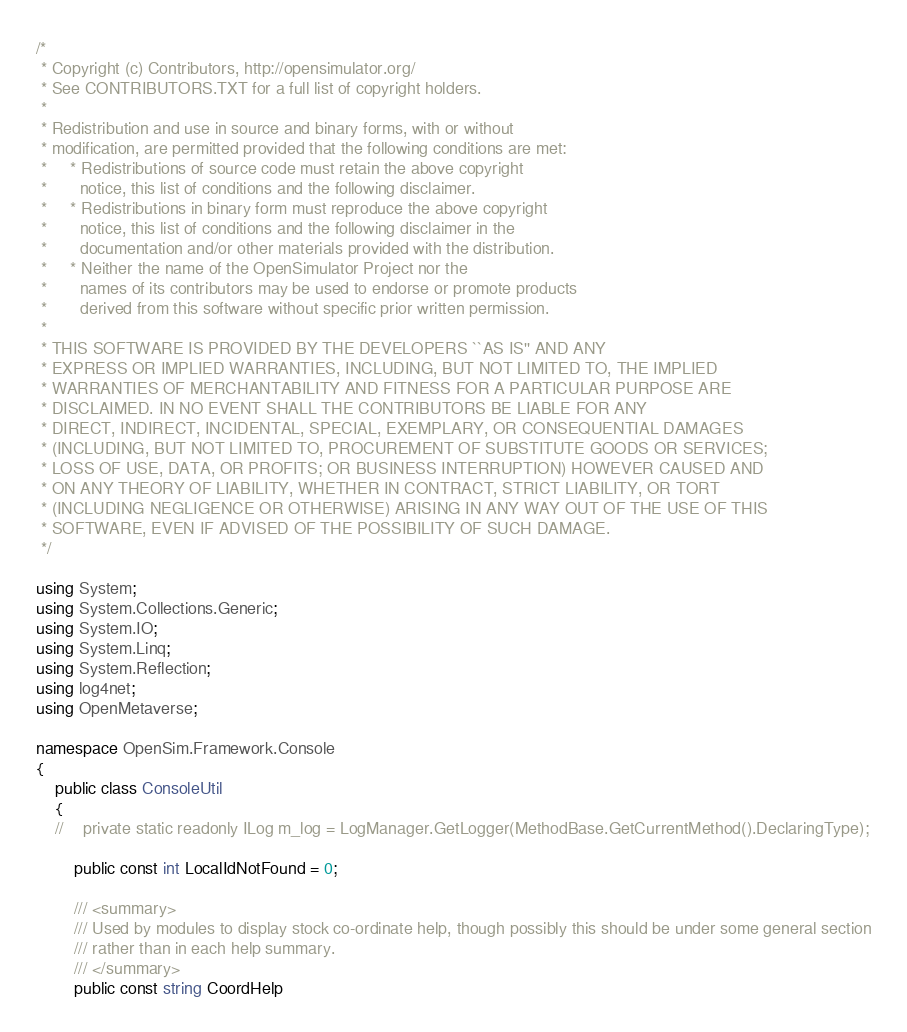<code> <loc_0><loc_0><loc_500><loc_500><_C#_>/*
 * Copyright (c) Contributors, http://opensimulator.org/
 * See CONTRIBUTORS.TXT for a full list of copyright holders.
 *
 * Redistribution and use in source and binary forms, with or without
 * modification, are permitted provided that the following conditions are met:
 *     * Redistributions of source code must retain the above copyright
 *       notice, this list of conditions and the following disclaimer.
 *     * Redistributions in binary form must reproduce the above copyright
 *       notice, this list of conditions and the following disclaimer in the
 *       documentation and/or other materials provided with the distribution.
 *     * Neither the name of the OpenSimulator Project nor the
 *       names of its contributors may be used to endorse or promote products
 *       derived from this software without specific prior written permission.
 *
 * THIS SOFTWARE IS PROVIDED BY THE DEVELOPERS ``AS IS'' AND ANY
 * EXPRESS OR IMPLIED WARRANTIES, INCLUDING, BUT NOT LIMITED TO, THE IMPLIED
 * WARRANTIES OF MERCHANTABILITY AND FITNESS FOR A PARTICULAR PURPOSE ARE
 * DISCLAIMED. IN NO EVENT SHALL THE CONTRIBUTORS BE LIABLE FOR ANY
 * DIRECT, INDIRECT, INCIDENTAL, SPECIAL, EXEMPLARY, OR CONSEQUENTIAL DAMAGES
 * (INCLUDING, BUT NOT LIMITED TO, PROCUREMENT OF SUBSTITUTE GOODS OR SERVICES;
 * LOSS OF USE, DATA, OR PROFITS; OR BUSINESS INTERRUPTION) HOWEVER CAUSED AND
 * ON ANY THEORY OF LIABILITY, WHETHER IN CONTRACT, STRICT LIABILITY, OR TORT
 * (INCLUDING NEGLIGENCE OR OTHERWISE) ARISING IN ANY WAY OUT OF THE USE OF THIS
 * SOFTWARE, EVEN IF ADVISED OF THE POSSIBILITY OF SUCH DAMAGE.
 */

using System;
using System.Collections.Generic;
using System.IO;
using System.Linq;
using System.Reflection;
using log4net;
using OpenMetaverse;

namespace OpenSim.Framework.Console
{
    public class ConsoleUtil
    {
    //    private static readonly ILog m_log = LogManager.GetLogger(MethodBase.GetCurrentMethod().DeclaringType);

        public const int LocalIdNotFound = 0;
    
        /// <summary>
        /// Used by modules to display stock co-ordinate help, though possibly this should be under some general section
        /// rather than in each help summary.
        /// </summary>
        public const string CoordHelp</code> 